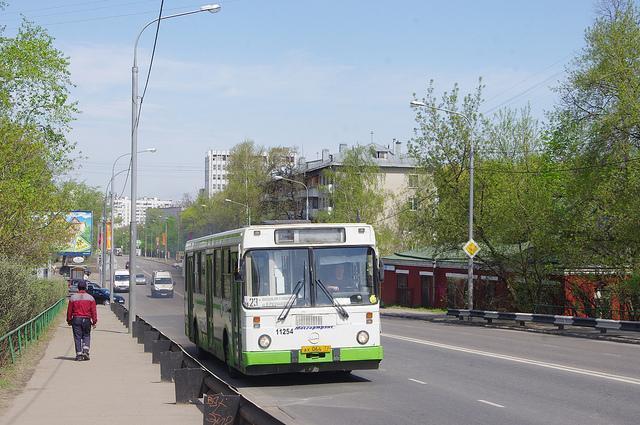How many colors is this bus?
Give a very brief answer. 2. How many zebras are seen?
Give a very brief answer. 0. 